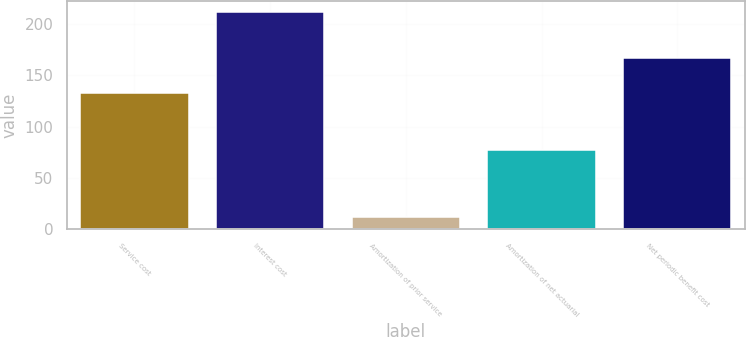<chart> <loc_0><loc_0><loc_500><loc_500><bar_chart><fcel>Service cost<fcel>Interest cost<fcel>Amortization of prior service<fcel>Amortization of net actuarial<fcel>Net periodic benefit cost<nl><fcel>133<fcel>212<fcel>12<fcel>77<fcel>167<nl></chart> 